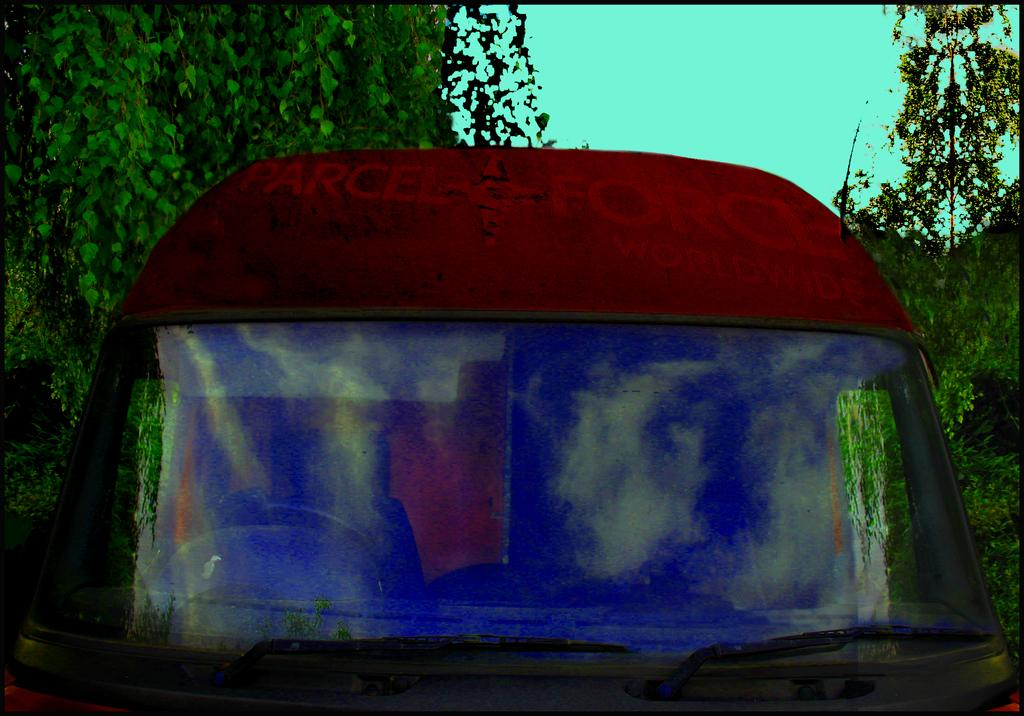What is the main subject of the image? There is a vehicle in the image. What color is the vehicle? The vehicle is red in color. Are there any unique features on the vehicle? Yes, the front glass of the vehicle is painted. What can be seen in the background of the image? There are trees visible behind the vehicle. What type of food is being served in the morning in the image? There is no food or mention of morning in the image; it features a red vehicle with painted front glass and trees in the background. 